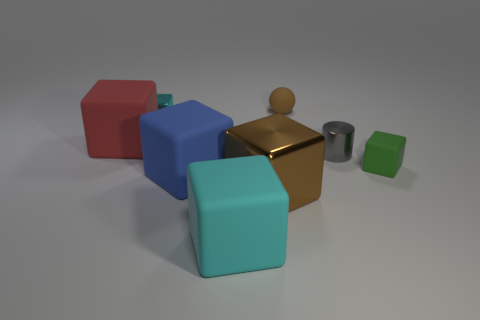What color is the other small cube that is the same material as the red cube?
Your answer should be compact. Green. The big metallic block has what color?
Give a very brief answer. Brown. Is the material of the tiny green object the same as the cyan block behind the big red rubber object?
Your response must be concise. No. How many rubber objects are both in front of the gray thing and on the right side of the brown metal cube?
Offer a terse response. 1. What is the shape of the green thing that is the same size as the sphere?
Make the answer very short. Cube. Are there any large brown metallic objects that are right of the brown object behind the metallic block on the left side of the big metallic cube?
Provide a succinct answer. No. There is a matte ball; is it the same color as the shiny thing that is right of the sphere?
Offer a very short reply. No. How many small balls are the same color as the tiny rubber cube?
Provide a succinct answer. 0. There is a cyan object that is on the left side of the cyan block that is in front of the tiny green matte object; what size is it?
Provide a succinct answer. Small. What number of objects are either tiny things that are on the left side of the small green thing or cubes?
Provide a short and direct response. 8. 